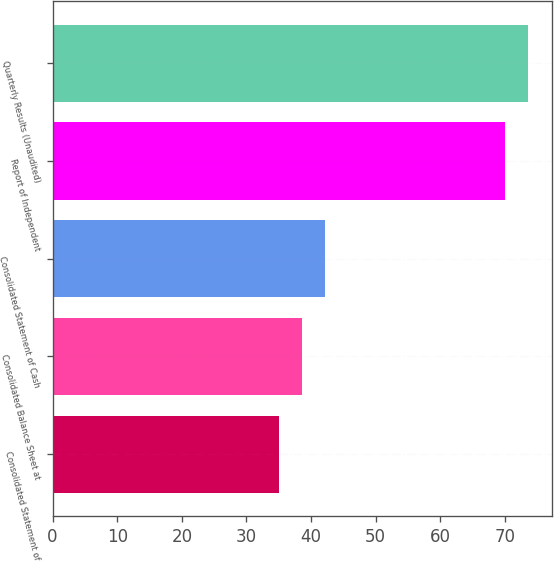Convert chart to OTSL. <chart><loc_0><loc_0><loc_500><loc_500><bar_chart><fcel>Consolidated Statement of<fcel>Consolidated Balance Sheet at<fcel>Consolidated Statement of Cash<fcel>Report of Independent<fcel>Quarterly Results (Unaudited)<nl><fcel>35<fcel>38.6<fcel>42.2<fcel>70<fcel>73.6<nl></chart> 